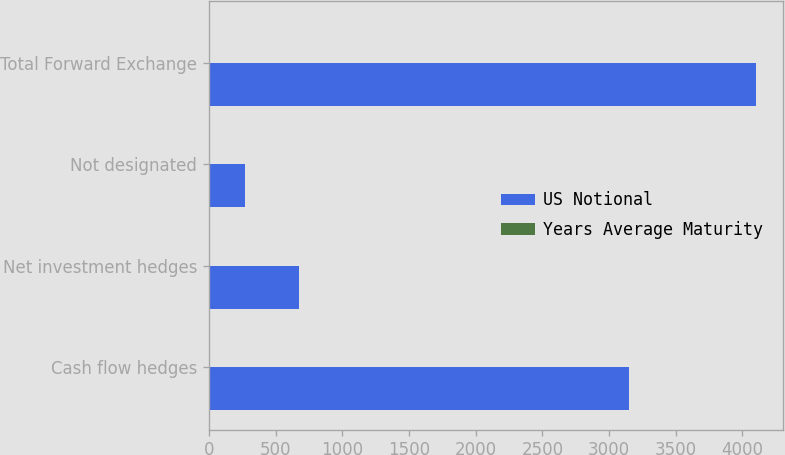Convert chart. <chart><loc_0><loc_0><loc_500><loc_500><stacked_bar_chart><ecel><fcel>Cash flow hedges<fcel>Net investment hedges<fcel>Not designated<fcel>Total Forward Exchange<nl><fcel>US Notional<fcel>3150.2<fcel>675.5<fcel>273.8<fcel>4099.5<nl><fcel>Years Average Maturity<fcel>0.4<fcel>3<fcel>0.1<fcel>0.8<nl></chart> 